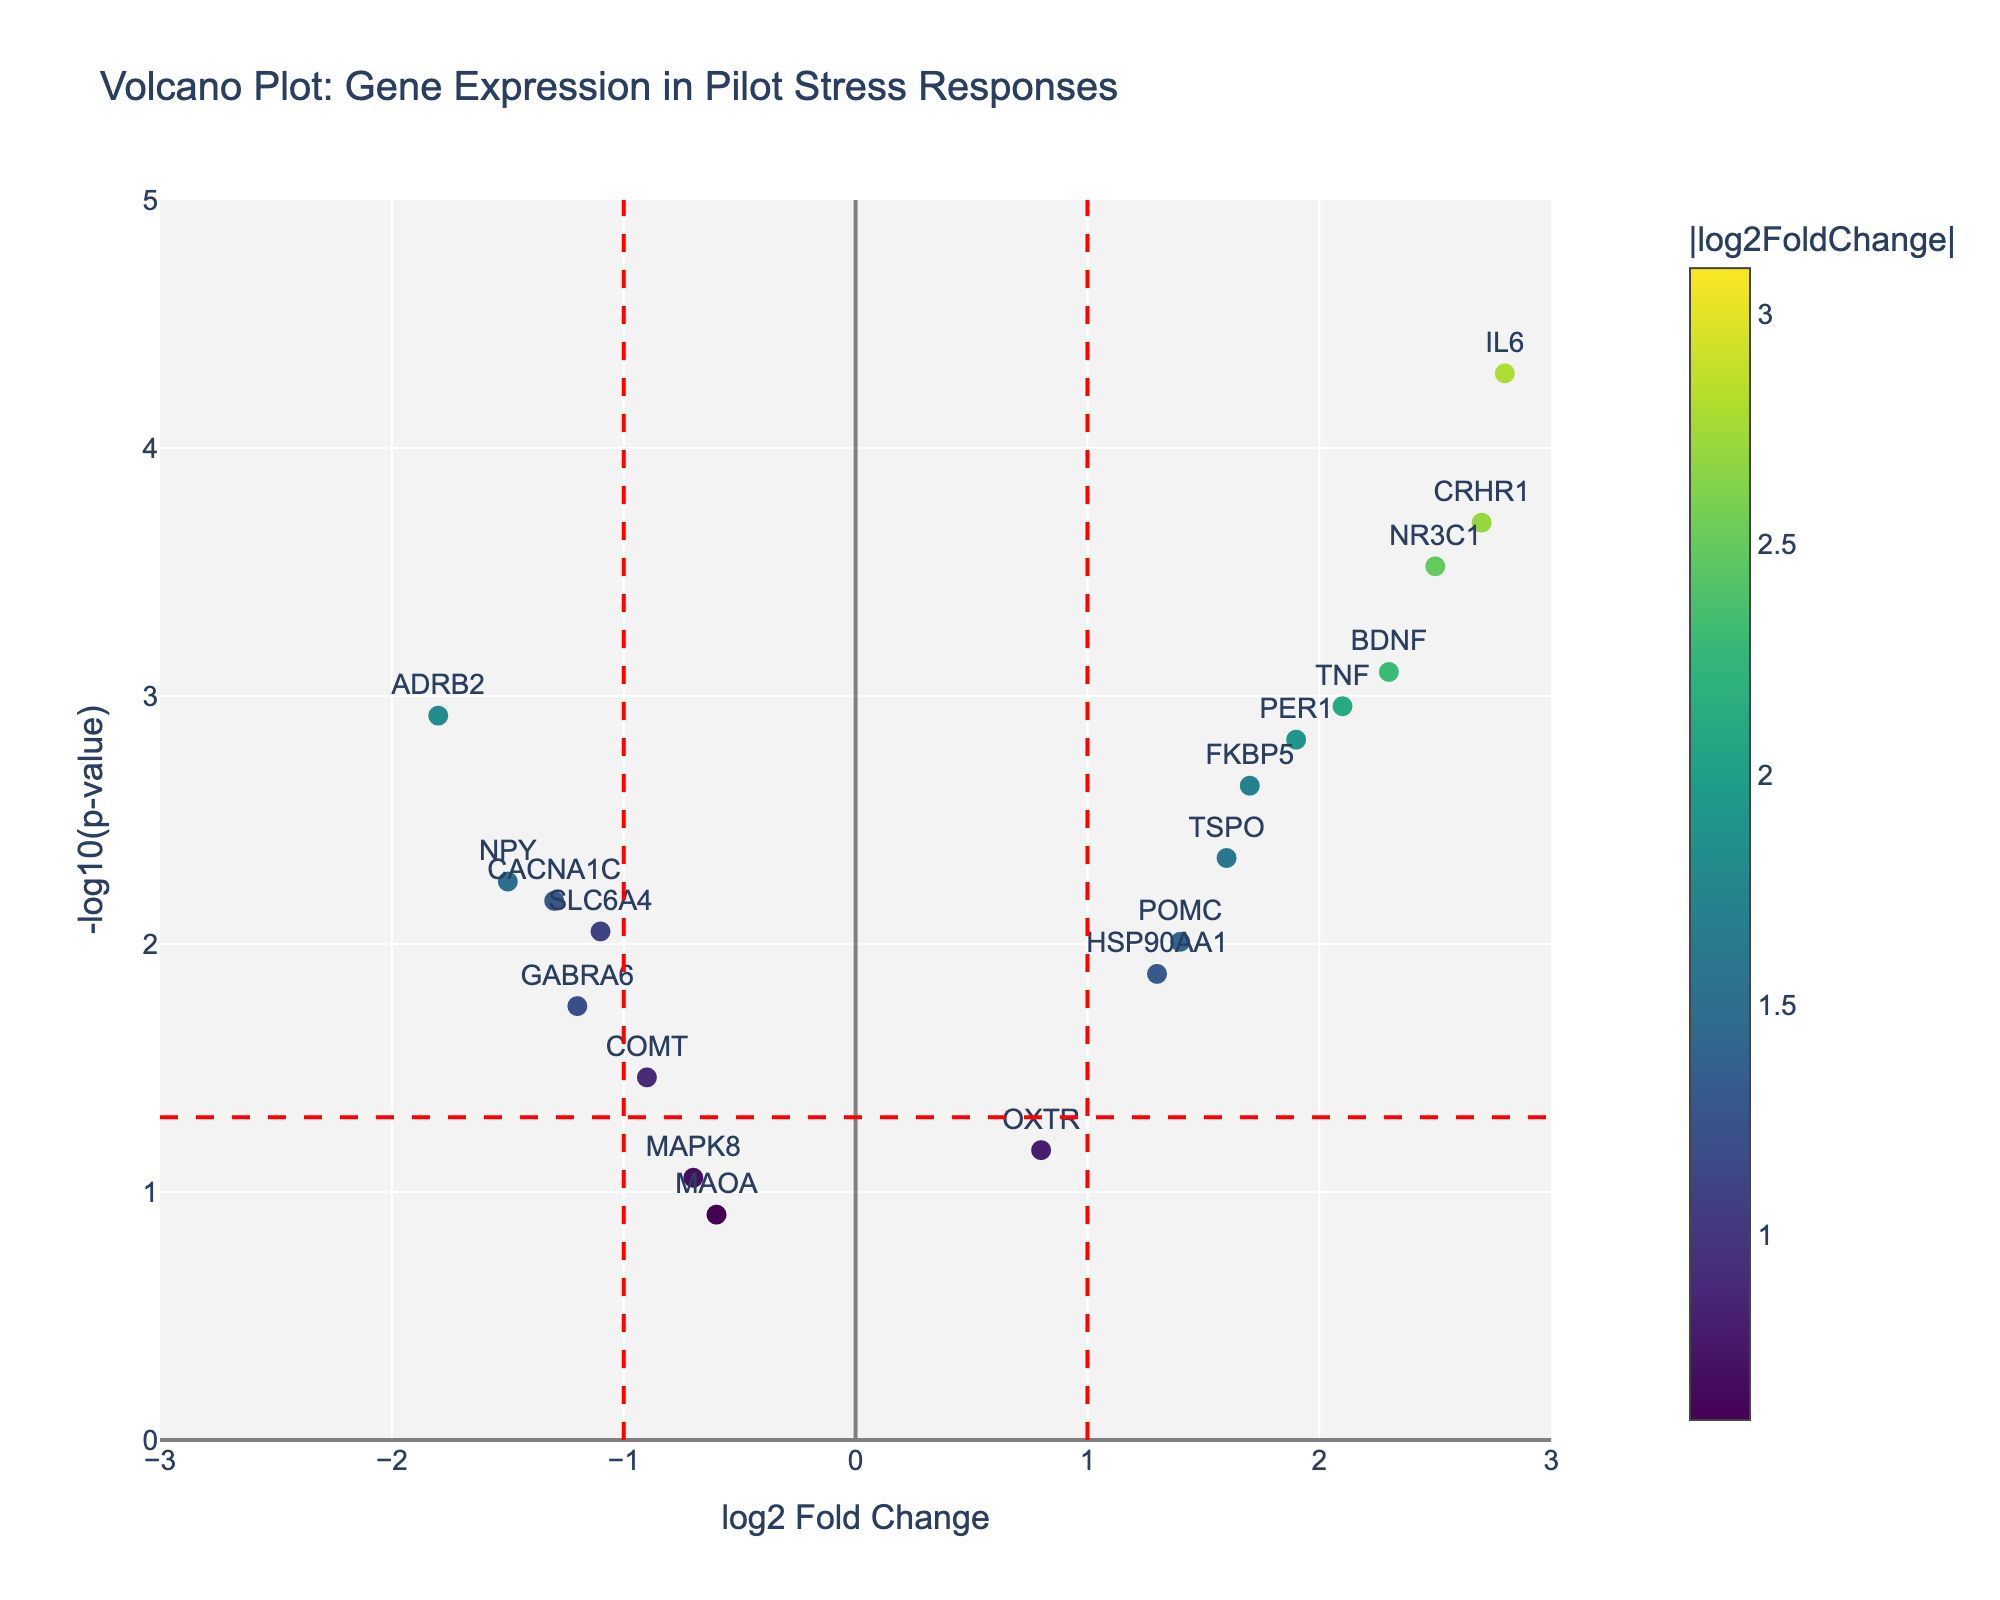Which gene has the highest log2 fold change? The highest log2 fold change can be observed by finding the data point farthest to the right on the x-axis. The gene CRH has the highest log2 fold change of 3.1.
Answer: CRH Which gene has the lowest p-value? The lowest p-value corresponds to the highest -log10(p-value) on the y-axis. The gene CRH is situated at the highest point on the y-axis with a p-value of 0.00001.
Answer: CRH How many genes have statistically significant changes? Statistically significant changes often use a threshold of p-value < 0.05, which corresponds to -log10(p-value) > 1.3. Count the number of points above this threshold. There are 16 genes with -log10(p-value) above 1.3.
Answer: 16 Which gene exhibits the most downregulated expression? Downregulation corresponds to negative log2 fold changes. The most downregulated gene will have the largest negative log2 fold change. The gene ADRB2 has the lowest log2 fold change at -1.8.
Answer: ADRB2 How many genes are both significantly upregulated and significant? Upregulated genes have positive log2 fold changes, and significance is determined by -log10(p-value) > 1.3. Count the number of genes that fulfill both conditions. There are 10 genes significantly upregulated.
Answer: 10 Between genes IL6 and TNF, which one has the higher significance? The significance is determined by the -log10(p-value) value. Comparing -log10(p-value) for IL6 and TNF, IL6 at 4.3010 has a higher value than TNF at 2.9586.
Answer: IL6 What is the log2 fold change of the GABRA6 gene? Locate the GABRA6 label, observe its position along the x-axis to find its log2 fold change. The log2 fold change for GABRA6 is -1.2.
Answer: -1.2 What threshold log2 fold change values are marked by the vertical lines? The vertical red dashed lines indicate the threshold values for significant fold changes. They are positioned at log2 fold changes of -1 and 1.
Answer: -1 and 1 